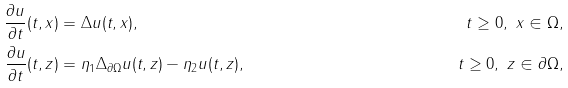<formula> <loc_0><loc_0><loc_500><loc_500>\frac { \partial u } { \partial t } ( t , x ) & = \Delta u ( t , x ) , \quad & t \geq 0 , \ x \in \Omega , \\ \frac { \partial u } { \partial t } ( t , z ) & = \eta _ { 1 } \Delta _ { \partial \Omega } u ( t , z ) - \eta _ { 2 } u ( t , z ) , \quad & t \geq 0 , \ z \in \partial \Omega ,</formula> 